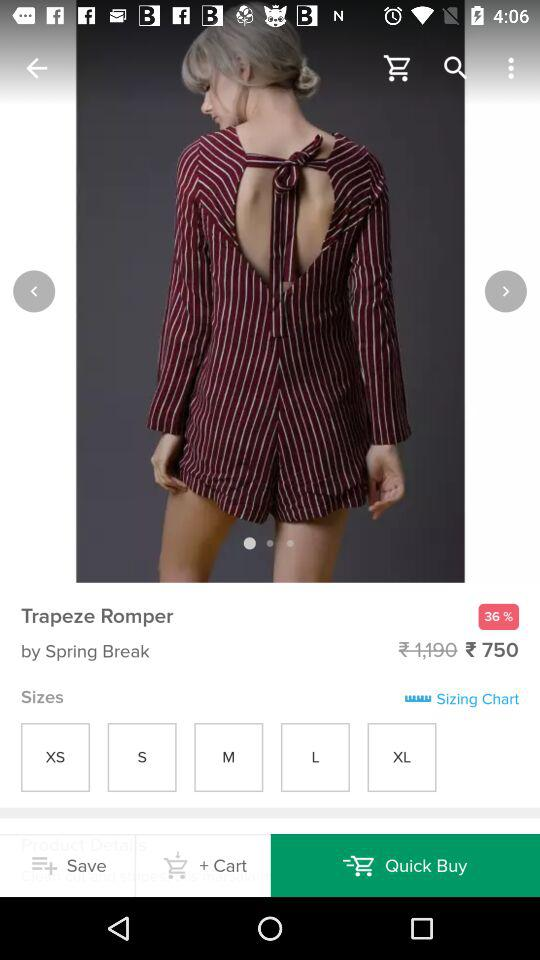What is the discount percentage? The discount percentage is 36. 